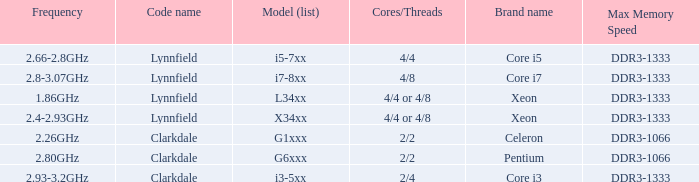What frequency does model L34xx use? 1.86GHz. Would you be able to parse every entry in this table? {'header': ['Frequency', 'Code name', 'Model (list)', 'Cores/Threads', 'Brand name', 'Max Memory Speed'], 'rows': [['2.66-2.8GHz', 'Lynnfield', 'i5-7xx', '4/4', 'Core i5', 'DDR3-1333'], ['2.8-3.07GHz', 'Lynnfield', 'i7-8xx', '4/8', 'Core i7', 'DDR3-1333'], ['1.86GHz', 'Lynnfield', 'L34xx', '4/4 or 4/8', 'Xeon', 'DDR3-1333'], ['2.4-2.93GHz', 'Lynnfield', 'X34xx', '4/4 or 4/8', 'Xeon', 'DDR3-1333'], ['2.26GHz', 'Clarkdale', 'G1xxx', '2/2', 'Celeron', 'DDR3-1066'], ['2.80GHz', 'Clarkdale', 'G6xxx', '2/2', 'Pentium', 'DDR3-1066'], ['2.93-3.2GHz', 'Clarkdale', 'i3-5xx', '2/4', 'Core i3', 'DDR3-1333']]} 